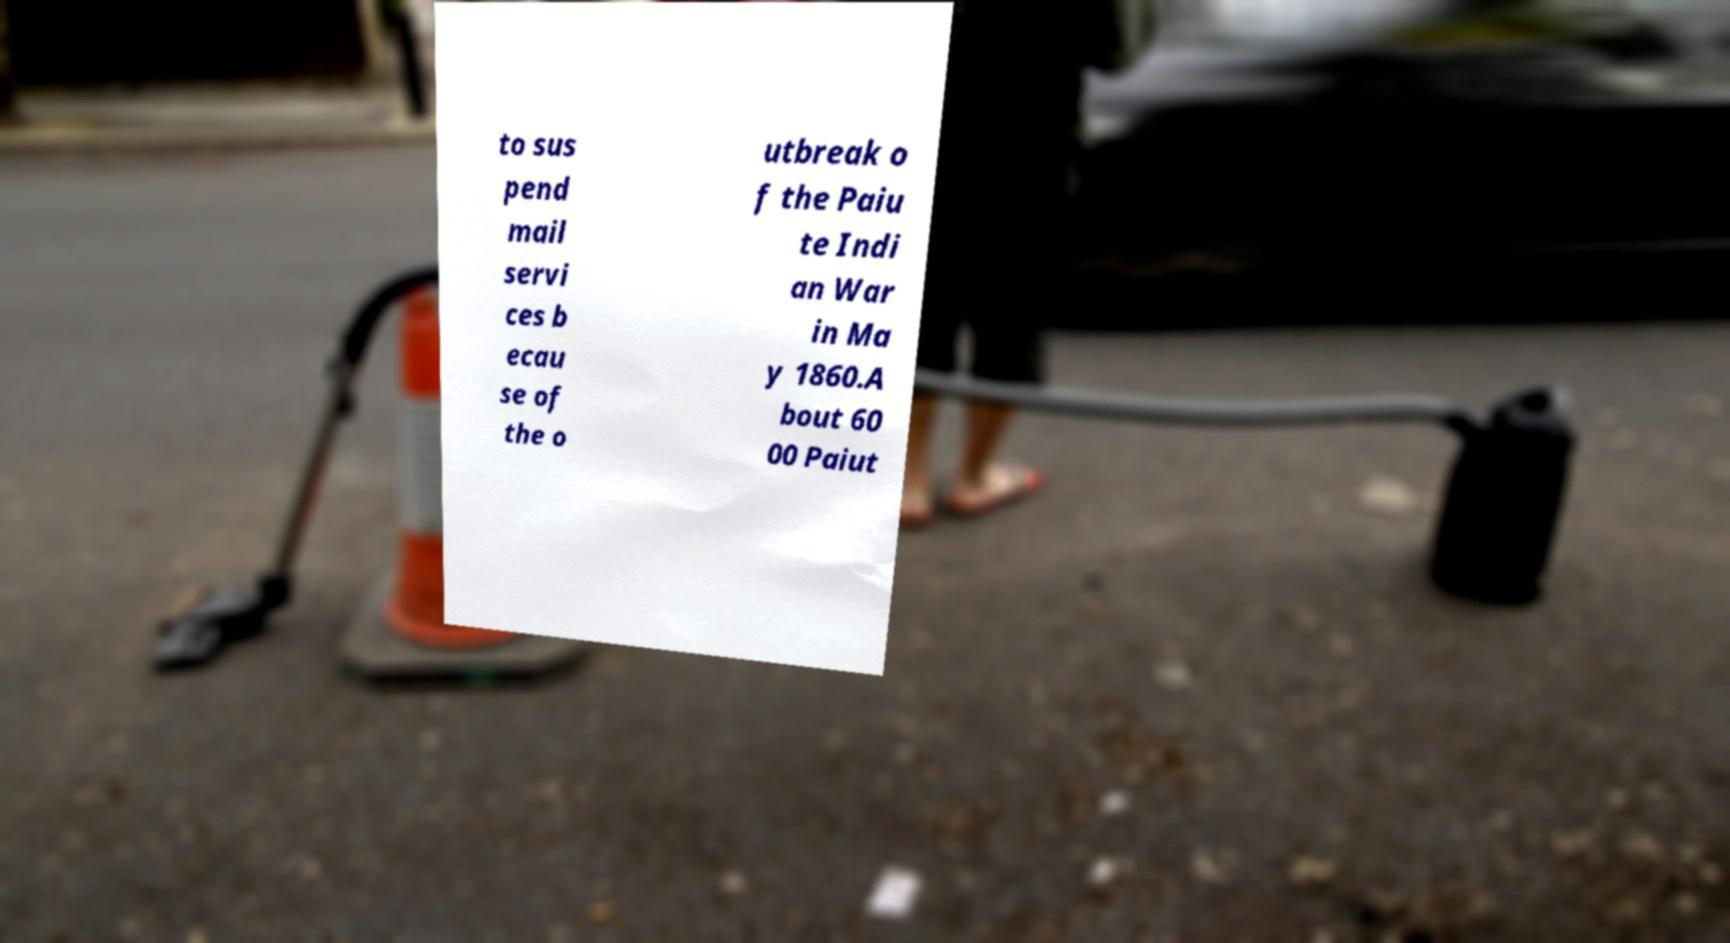For documentation purposes, I need the text within this image transcribed. Could you provide that? to sus pend mail servi ces b ecau se of the o utbreak o f the Paiu te Indi an War in Ma y 1860.A bout 60 00 Paiut 